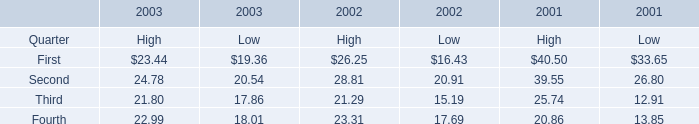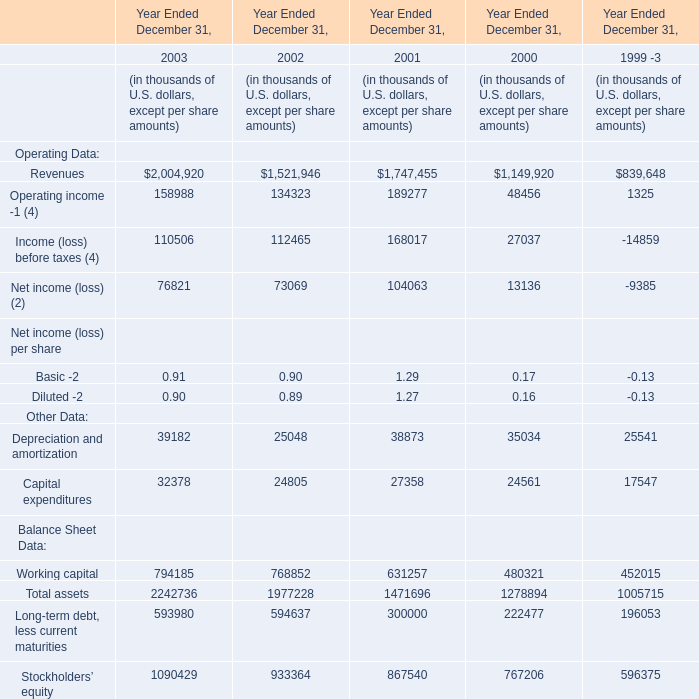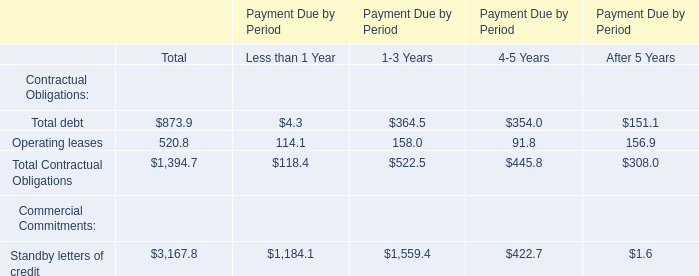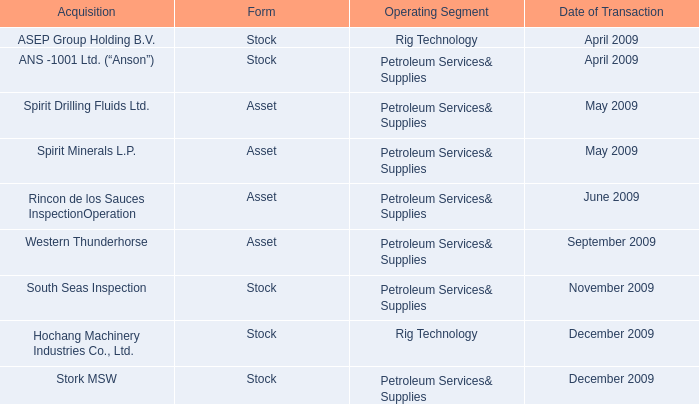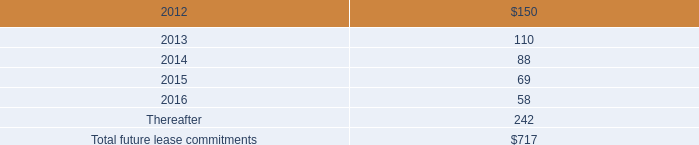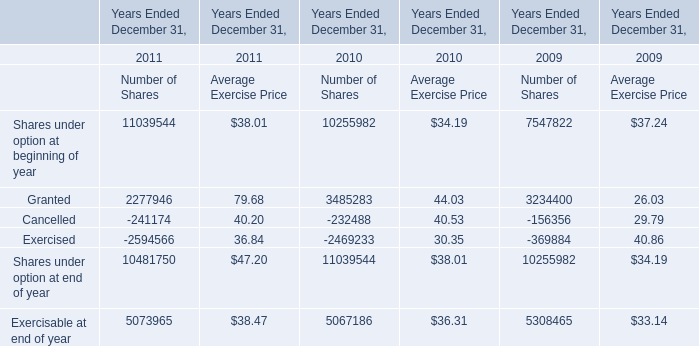what was the difference in millions of cash payments for federal , state , and foreign income taxes between 2014 and 2015? 
Computations: (238.3 - 189.5)
Answer: 48.8. 